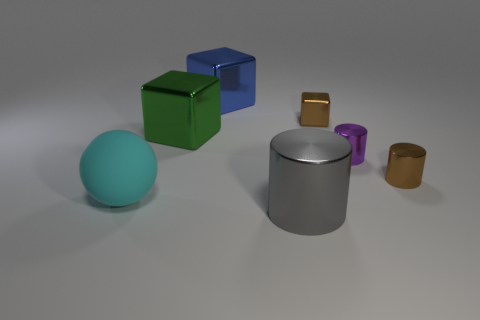Subtract all large metallic blocks. How many blocks are left? 1 Add 1 brown shiny cylinders. How many objects exist? 8 Subtract 1 gray cylinders. How many objects are left? 6 Subtract all cylinders. How many objects are left? 4 Subtract all yellow cylinders. Subtract all blue balls. How many cylinders are left? 3 Subtract all gray blocks. How many gray cylinders are left? 1 Subtract all tiny brown rubber things. Subtract all large cyan rubber things. How many objects are left? 6 Add 2 large cylinders. How many large cylinders are left? 3 Add 3 brown cubes. How many brown cubes exist? 4 